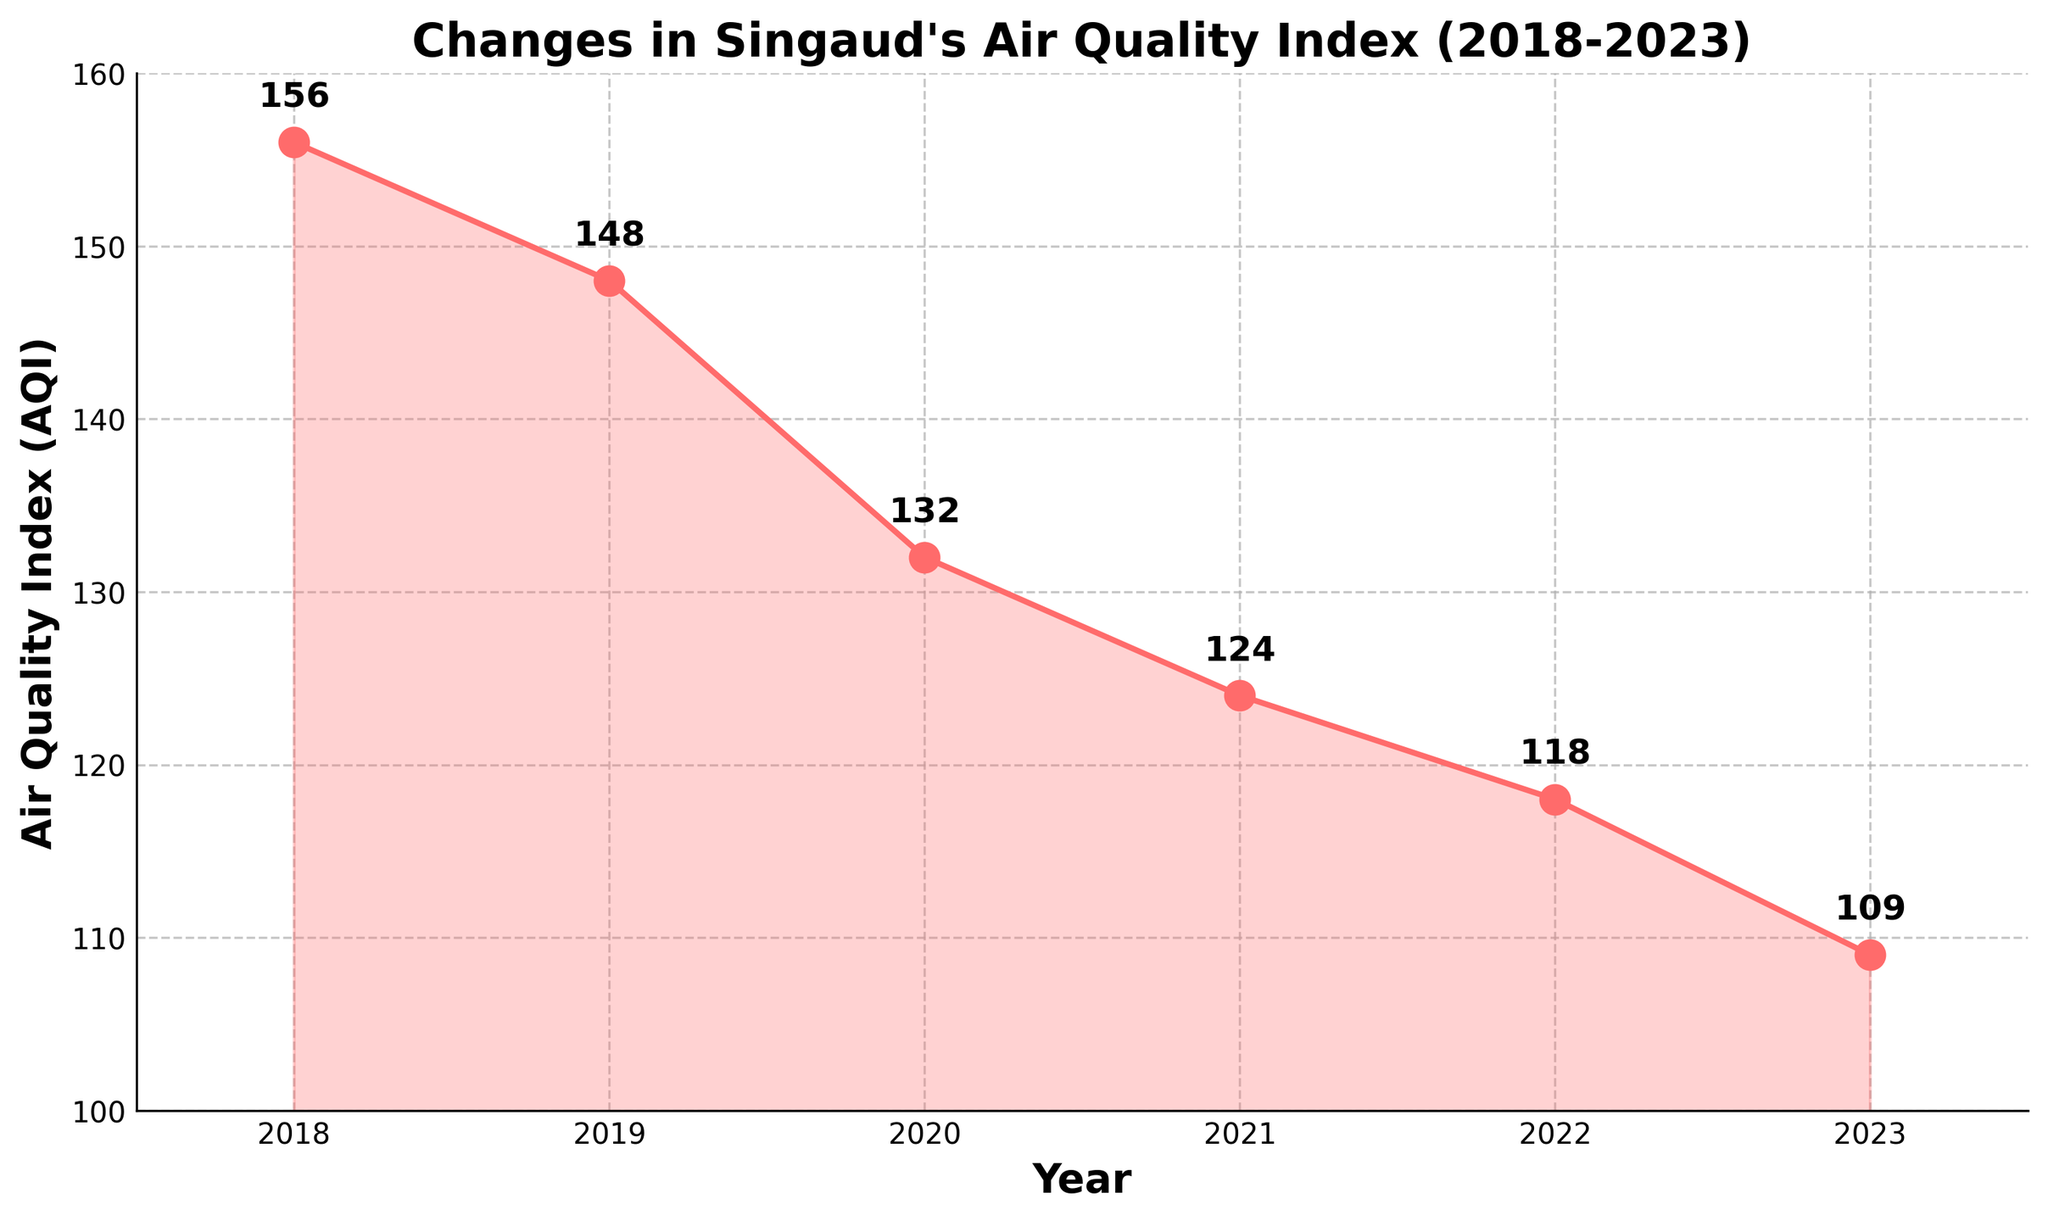what's the average AQI across all years? To find the average AQI, sum up the AQI values for all years and divide by the number of years: (156 + 148 + 132 + 124 + 118 + 109) / 6 = 787 / 6 = 131.17
Answer: 131.17 which year had the highest AQI? The year with the highest AQI is the one with the highest data point on the line chart. From the figure, 2018 had the highest AQI of 156.
Answer: 2018 how much did the AQI decrease from 2018 to 2023? Subtract the AQI in 2023 from the AQI in 2018: 156 - 109 = 47.
Answer: 47 what's the trend of the AQI over the years? The line chart shows a steady downward trend from 2018 to 2023, indicating a decrease in AQI each year.
Answer: decreasing which year had the smallest change in AQI compared to the previous year? By observing the changes, the smallest change occurs between 2021 and 2022: 124 - 118 = 6.
Answer: 2022 compare the AQI of 2019 and 2020. The AQI in 2019 is 148, and in 2020 is 132. Since 148 > 132, the AQI decreased from 2019 to 2020.
Answer: 2019 > 2020 what's the median AQI value of the years shown? Arrange the AQI values in order: 109, 118, 124, 132, 148, 156. The median is the average of the 3rd and 4th values: (124 + 132) / 2 = 128.
Answer: 128 what is the range of AQI values? The range is the difference between the maximum and minimum AQI values: 156 - 109 = 47.
Answer: 47 describe the color and style used for the plot line and points. The line is red and has circular markers at each data point. The line is also filled with a lighter shade of the same color below it.
Answer: red with circular markers 